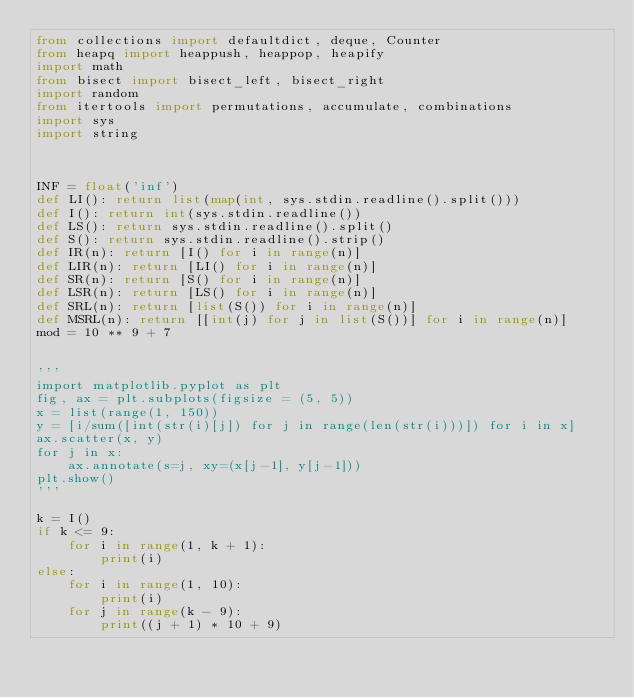<code> <loc_0><loc_0><loc_500><loc_500><_Python_>from collections import defaultdict, deque, Counter
from heapq import heappush, heappop, heapify
import math
from bisect import bisect_left, bisect_right
import random
from itertools import permutations, accumulate, combinations
import sys
import string



INF = float('inf')
def LI(): return list(map(int, sys.stdin.readline().split()))
def I(): return int(sys.stdin.readline())
def LS(): return sys.stdin.readline().split()
def S(): return sys.stdin.readline().strip()
def IR(n): return [I() for i in range(n)]
def LIR(n): return [LI() for i in range(n)]
def SR(n): return [S() for i in range(n)]
def LSR(n): return [LS() for i in range(n)]
def SRL(n): return [list(S()) for i in range(n)]
def MSRL(n): return [[int(j) for j in list(S())] for i in range(n)]
mod = 10 ** 9 + 7


'''
import matplotlib.pyplot as plt
fig, ax = plt.subplots(figsize = (5, 5))
x = list(range(1, 150))
y = [i/sum([int(str(i)[j]) for j in range(len(str(i)))]) for i in x]
ax.scatter(x, y)
for j in x:
    ax.annotate(s=j, xy=(x[j-1], y[j-1]))
plt.show()
'''

k = I()
if k <= 9:
    for i in range(1, k + 1):
        print(i)
else:
    for i in range(1, 10):
        print(i)
    for j in range(k - 9):
        print((j + 1) * 10 + 9)




</code> 